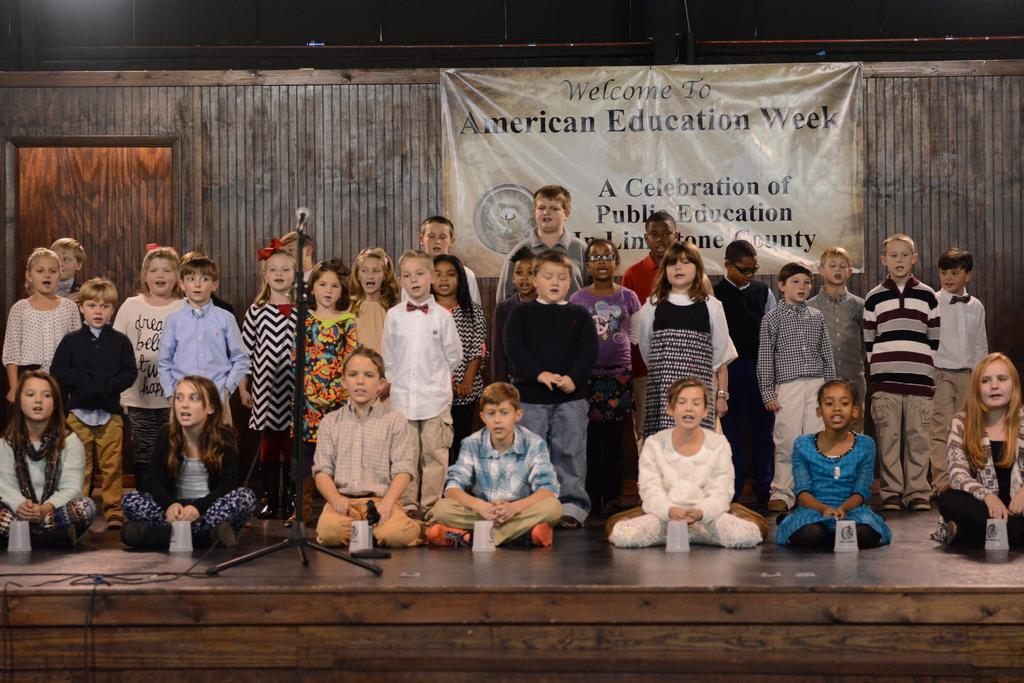What are the kids in the image doing? Some kids are standing, while others are sitting in the image. What can be seen on the left side of the image? There is a black color microphone on the left side of the image. What is visible in the background of the image? There is a poster visible in the background of the image. Can you tell me how many kittens are playing basketball in the image? There are no kittens or basketballs present in the image. What type of bells can be heard ringing in the background of the image? There is no sound or mention of bells in the image. 